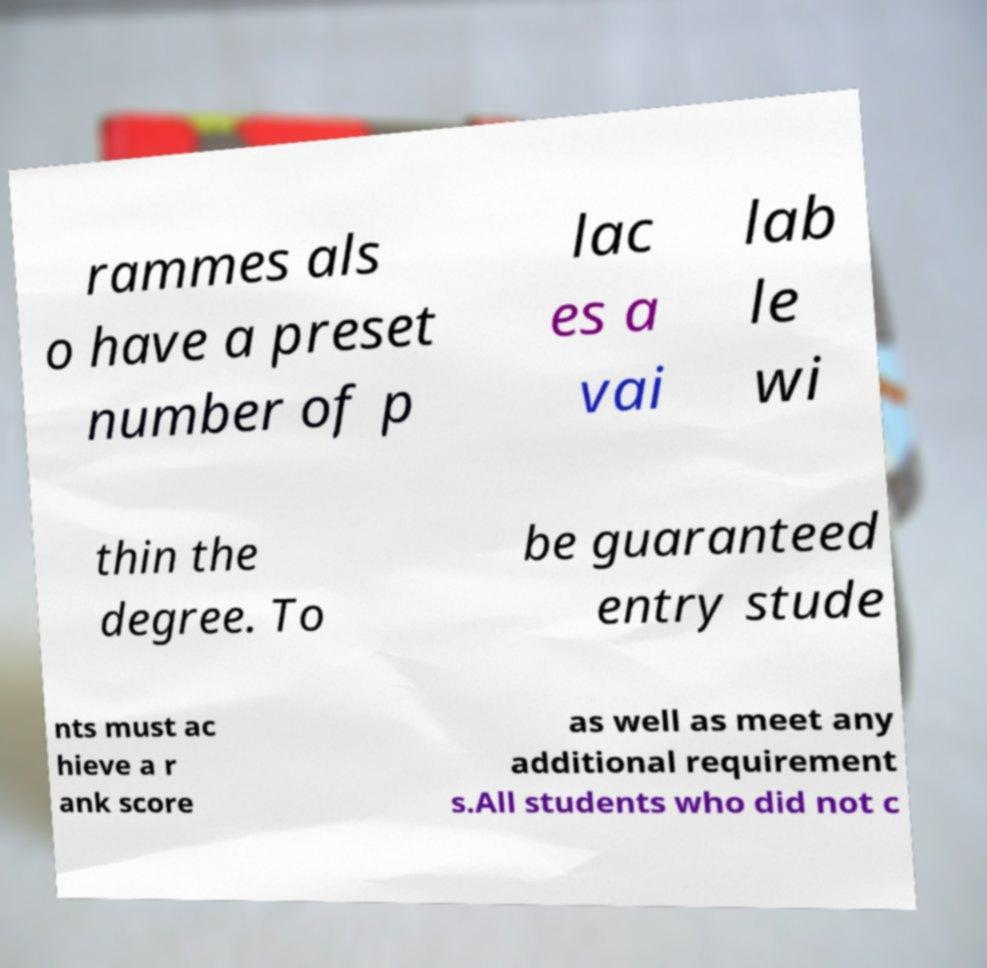For documentation purposes, I need the text within this image transcribed. Could you provide that? rammes als o have a preset number of p lac es a vai lab le wi thin the degree. To be guaranteed entry stude nts must ac hieve a r ank score as well as meet any additional requirement s.All students who did not c 